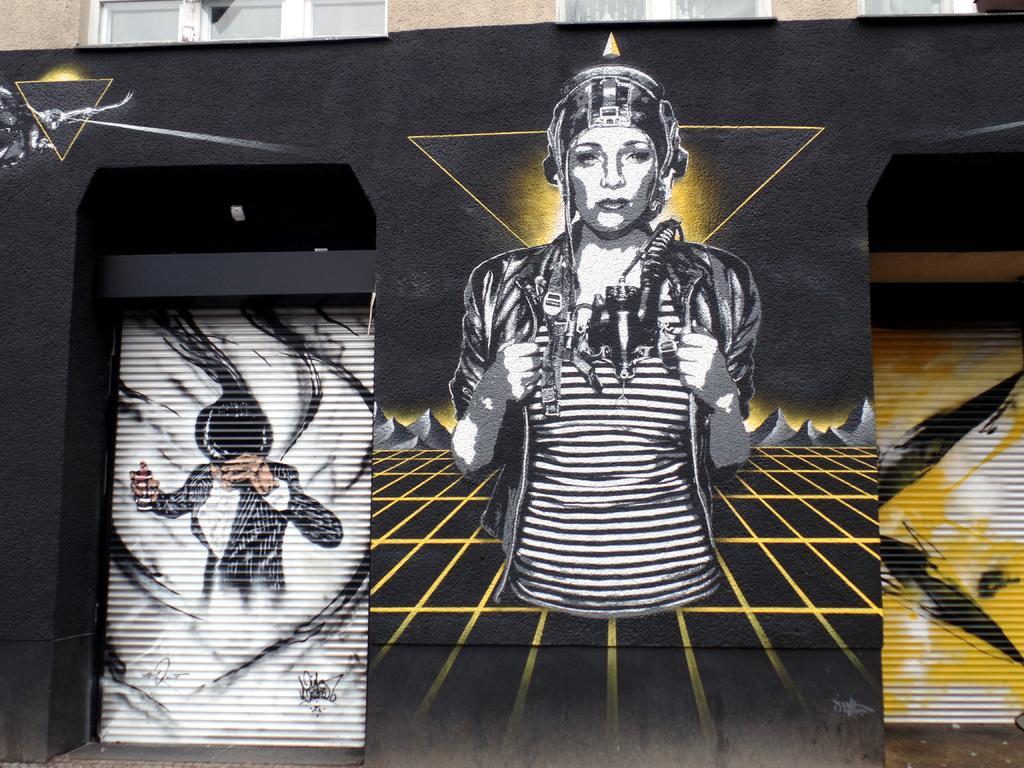Could you give a brief overview of what you see in this image? In this image I can see the depiction on the wall. 